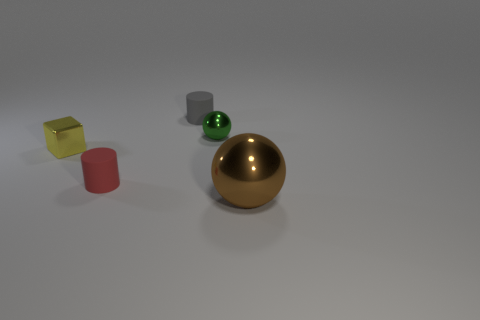Add 4 small metal things. How many objects exist? 9 Subtract all cylinders. How many objects are left? 3 Subtract all small green metallic balls. Subtract all tiny green metal objects. How many objects are left? 3 Add 2 tiny objects. How many tiny objects are left? 6 Add 3 large brown objects. How many large brown objects exist? 4 Subtract 0 red blocks. How many objects are left? 5 